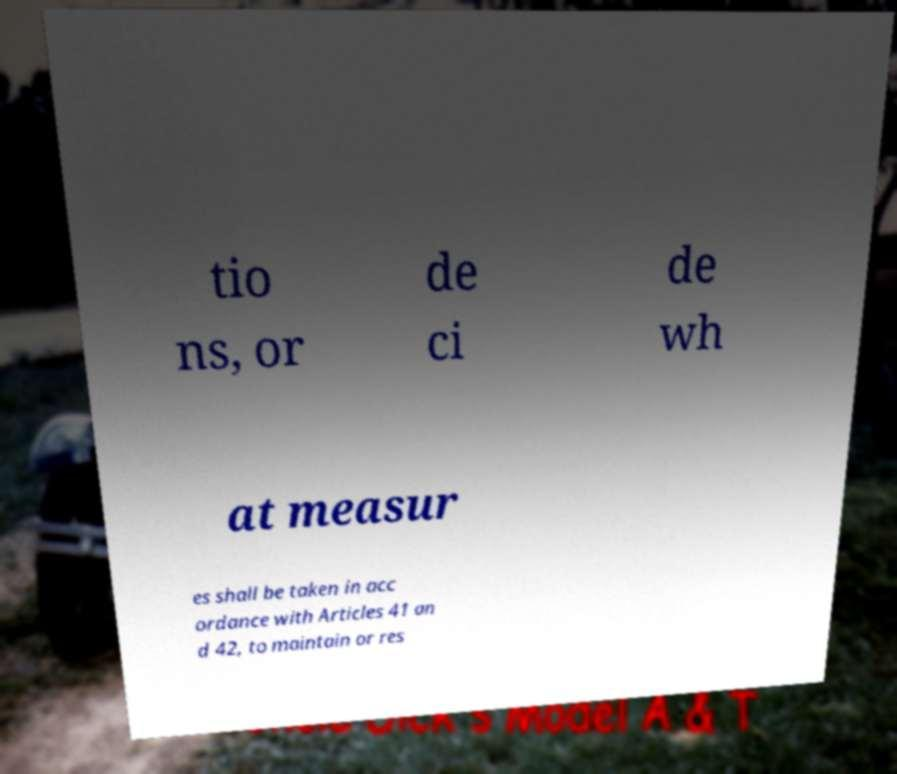Please identify and transcribe the text found in this image. tio ns, or de ci de wh at measur es shall be taken in acc ordance with Articles 41 an d 42, to maintain or res 